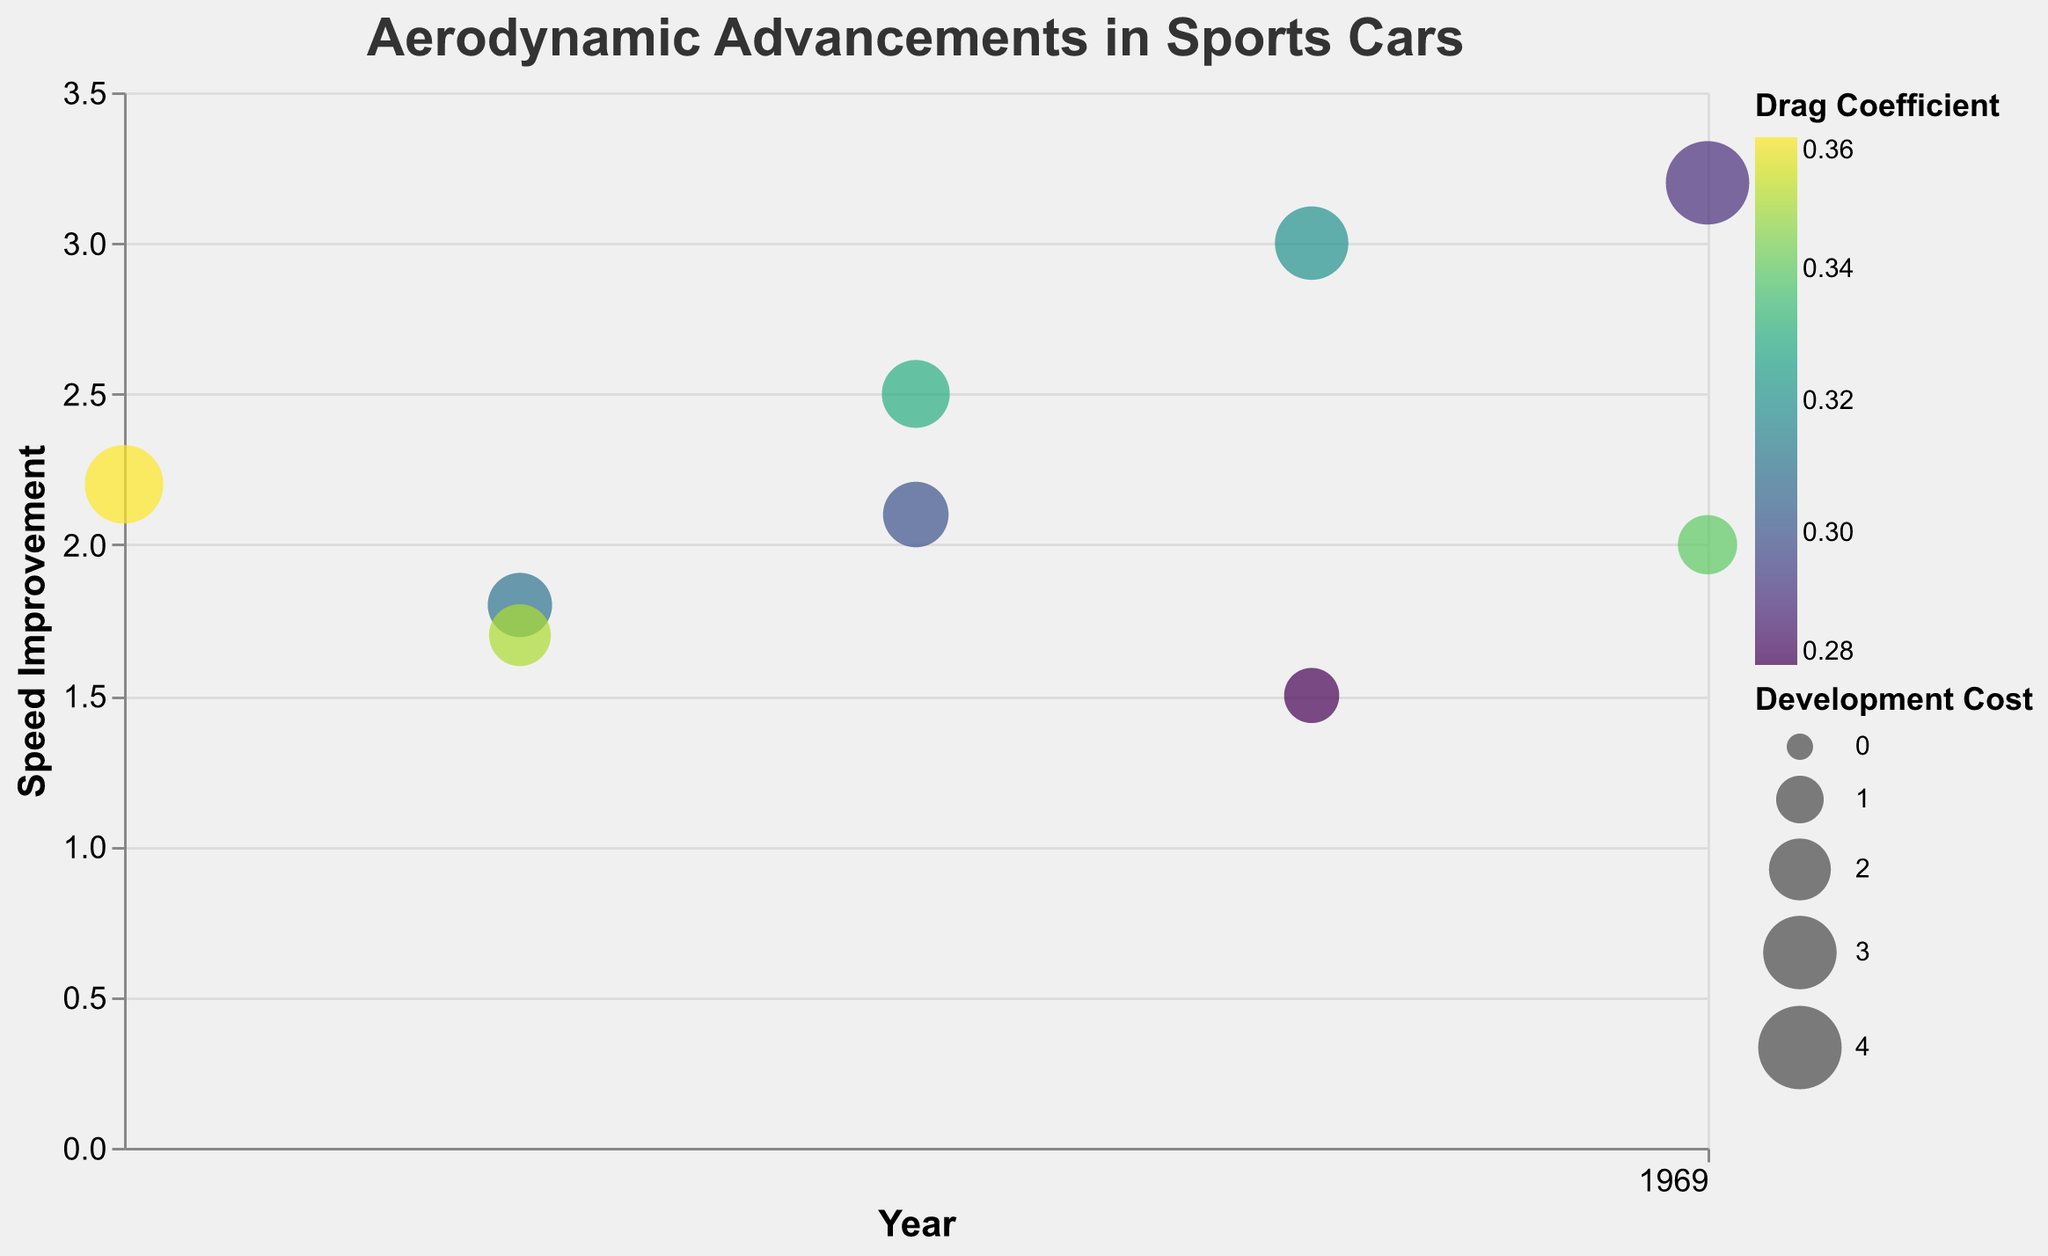What is the title of the chart? The title of the chart is located at the top and clearly states the main topic being visualized. Upon examination, the title reads "Aerodynamic Advancements in Sports Cars".
Answer: Aerodynamic Advancements in Sports Cars Which sports car model has the highest speed improvement, and what is its corresponding technological advancement? To find the highest speed improvement, look at the y-axis for the maximum value. The highest value on the y-axis is 3.2, which corresponds to the "Aero Blades" technological advancement used in the "Aston Martin Valkyrie".
Answer: Aston Martin Valkyrie, Aero Blades What year had the lowest drag coefficient, and which car model had this value? Check the color legend where darker values indicate a lower drag coefficient. The "Chevrolet Corvette C8" in 2019 is the car with the lowest drag coefficient of 0.28.
Answer: 2019, Chevrolet Corvette C8 What is the average speed improvement for sports cars with a development cost of over 2.5? First, identify cars with a development cost greater than 2.5, which are "Ferrari 488 Pista" (3.0), "Bugatti Chiron" (3.5), and "Aston Martin Valkyrie" (4.0). Their speed improvements are 3.0, 2.2, and 3.2 respectively. The average is calculated as (3.0 + 2.2 + 3.2) / 3 = 2.8.
Answer: 2.8 Which technological advancement was introduced in 2018 and what is its development cost? Locate the points for the year 2018 on the x-axis and read their associated technological advancements and development costs from the tooltip. For 2018, the advancements are "Active Aerodynamics" with a cost of 2.5 and "Advanced Winglets" with a cost of 2.3.
Answer: Active Aerodynamics: 2.5, Advanced Winglets: 2.3 How many bubbles represent advancements introduced in 2020, and what are their speed improvements? By checking the x-axis at the year 2020, there are two data points: "Adaptive Spoilers" and "Aero Blades". The speed improvements for these are 2.0 and 3.2 respectively.
Answer: 2, 2.0 and 3.2 Which sports car model has the least development cost, and what was the speed improvement and drag coefficient associated with it? Identify the smallest bubble size from the visual representation, which indicates the lowest development cost. The smallest bubble corresponds to the "Chevrolet Corvette C8" with a cost of 1.5 and a speed improvement of 1.5 and drag coefficient of 0.28.
Answer: Chevrolet Corvette C8, 1.5, 0.28 Compare the drag coefficients of the technological advancements introduced in 2017. Which one had a lower drag coefficient? Observe the two advancements from 2017: "Rear Diffusers" and "Front Splitters". The drag coefficients are 0.31 and 0.35, respectively. The lower drag coefficient is associated with "Rear Diffusers".
Answer: Rear Diffusers 